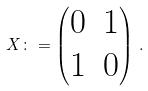<formula> <loc_0><loc_0><loc_500><loc_500>X \colon = \begin{pmatrix} 0 & 1 \\ 1 & 0 \end{pmatrix} \, .</formula> 